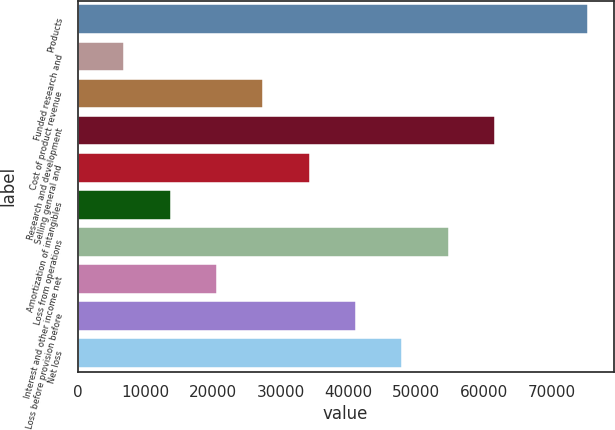Convert chart to OTSL. <chart><loc_0><loc_0><loc_500><loc_500><bar_chart><fcel>Products<fcel>Funded research and<fcel>Cost of product revenue<fcel>Research and development<fcel>Selling general and<fcel>Amortization of intangibles<fcel>Loss from operations<fcel>Interest and other income net<fcel>Loss before provision before<fcel>Net loss<nl><fcel>75367.5<fcel>6852.38<fcel>27406.9<fcel>61664.5<fcel>34258.4<fcel>13703.9<fcel>54812.9<fcel>20555.4<fcel>41109.9<fcel>47961.4<nl></chart> 